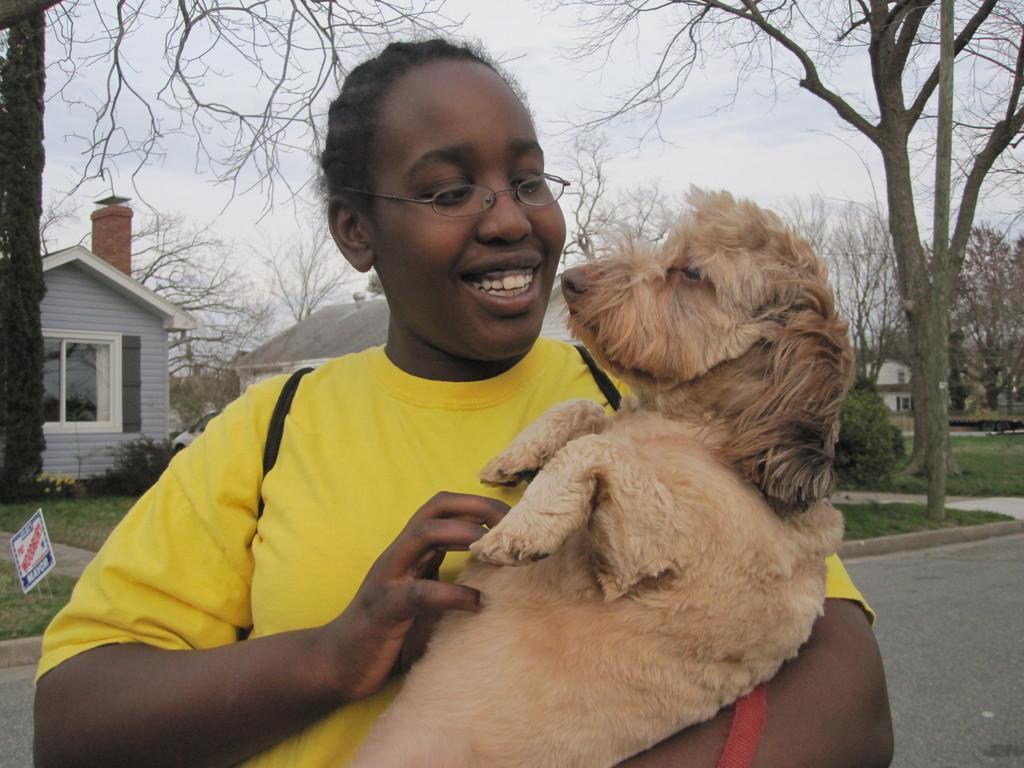Can you describe this image briefly? In this picture we can see a woman,she is carrying a dog and in the background we can see buildings,trees,sky. 